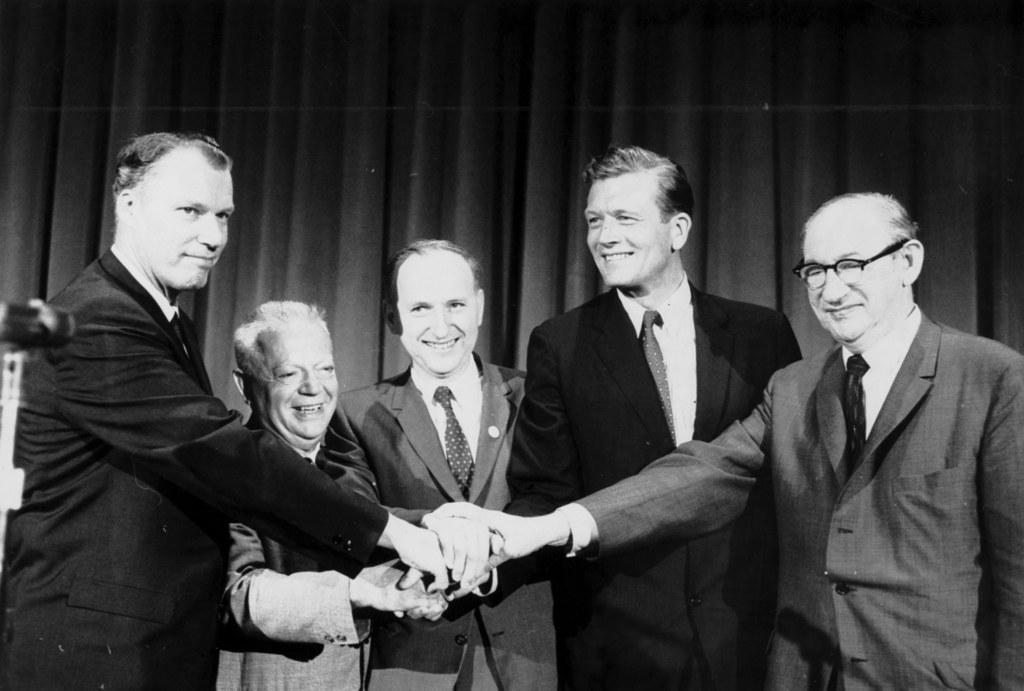How many people are in the image? There are persons in the image, but the exact number is not specified. What are the people wearing in the image? The persons are wearing clothes in the image. What is the color scheme of the image? The image is black and white. What can be seen in the background of the image? There are vertical window blinds in the background of the image. What type of curve can be seen in the image? There is no curve present in the image; it features persons wearing clothes in a black and white setting with vertical window blinds in the background. 